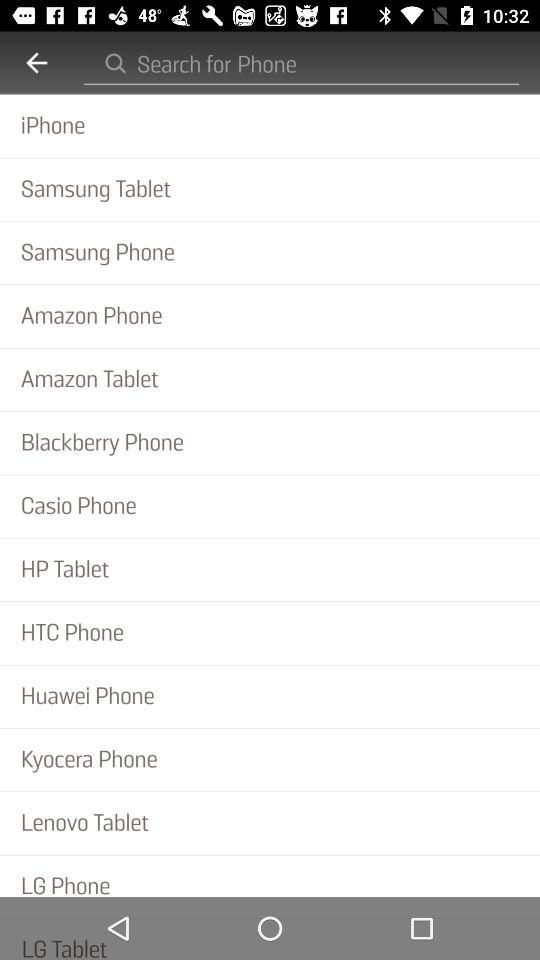What are the names of the phone brands? The names of the phone brands are "iPhone", "Samsung", "Amazon", "Blackberry", "Casio", "HTC", "Huawei", "Kyocera" and "LG". 